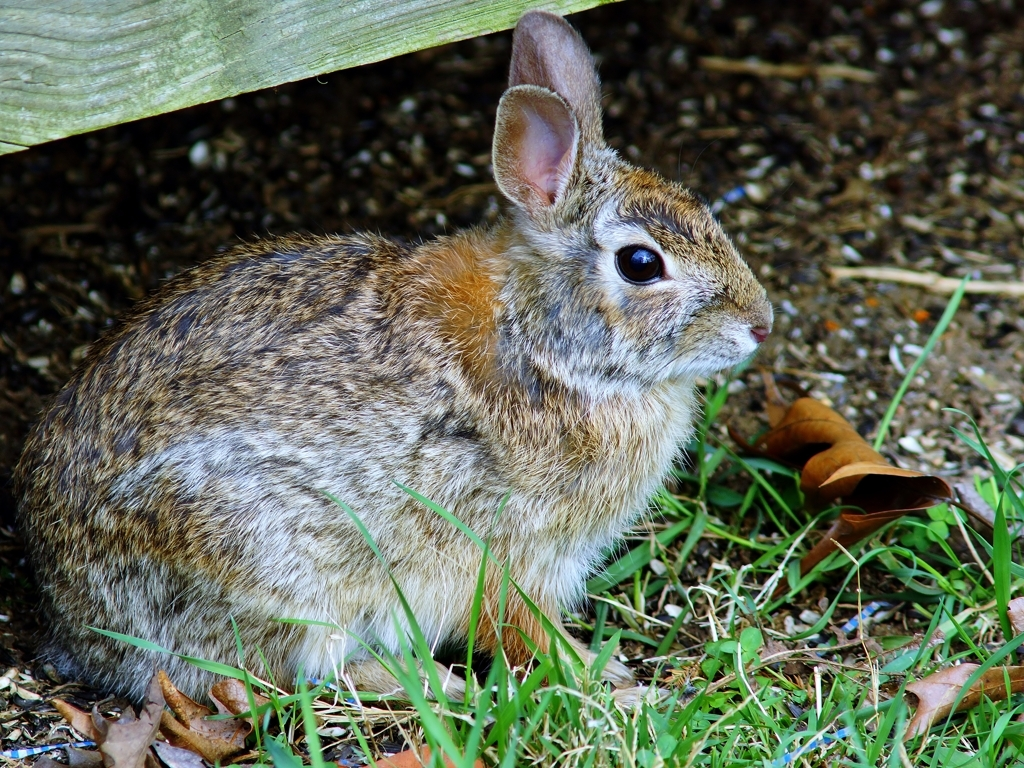What time of day does this photo seem to have been taken at, and what clues indicate this? The photo appears to have been taken during the day, most likely in the late morning or early afternoon. This is indicated by the bright, even lighting and the absence of long shadows that would be present early or late in the day. 